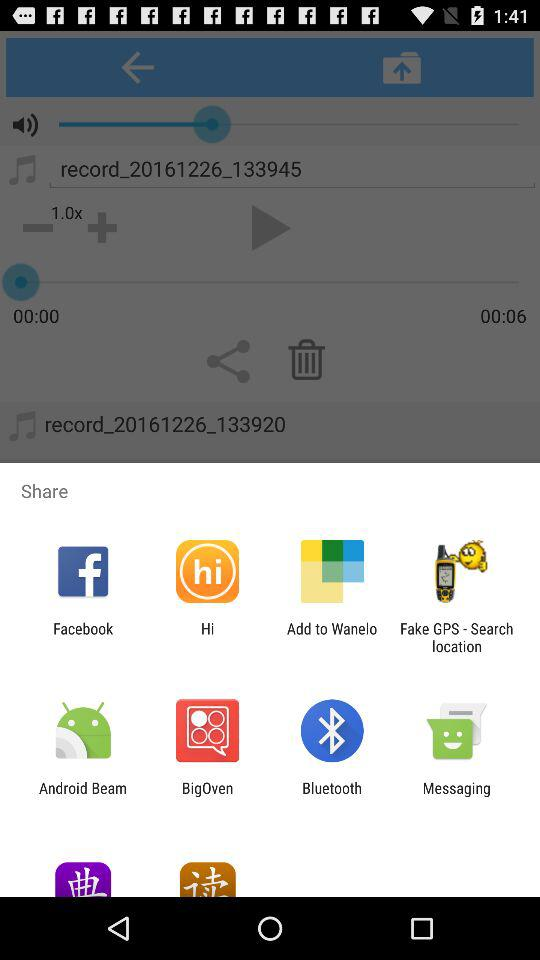How many more seconds are in the second time stamp than the first?
Answer the question using a single word or phrase. 6 